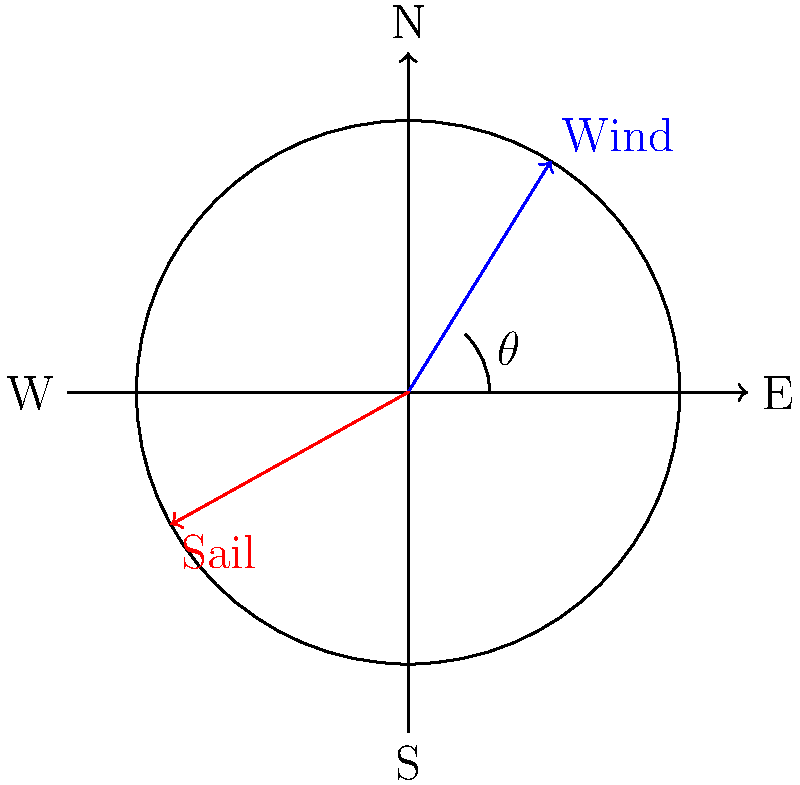In the wind direction diagram shown, the wind is coming from the northeast (45° from north). What is the optimal sail angle $\alpha$ relative to the wind direction for maximum propulsion? To find the optimal sail angle for maximum wind propulsion, we need to follow these steps:

1. Understand the principle: The optimal sail angle is typically halfway between the wind direction and the boat's heading (assuming the boat is sailing directly into the wind).

2. Identify the wind direction: In this case, the wind is coming from 45° (northeast).

3. Calculate the optimal sail angle:
   - The sail should be positioned halfway between the wind direction and the boat's heading.
   - Mathematically, this is expressed as: $\alpha = \frac{\theta}{2}$
   - Where $\theta$ is the angle between the wind direction and the boat's heading.

4. In this case, if we assume the boat is sailing directly into the wind:
   $\alpha = \frac{45°}{2} = 22.5°$

5. Therefore, the optimal sail angle relative to the wind direction is 22.5°.

This angle allows the sail to capture the maximum amount of wind energy while minimizing drag, resulting in optimal propulsion.
Answer: 22.5° 